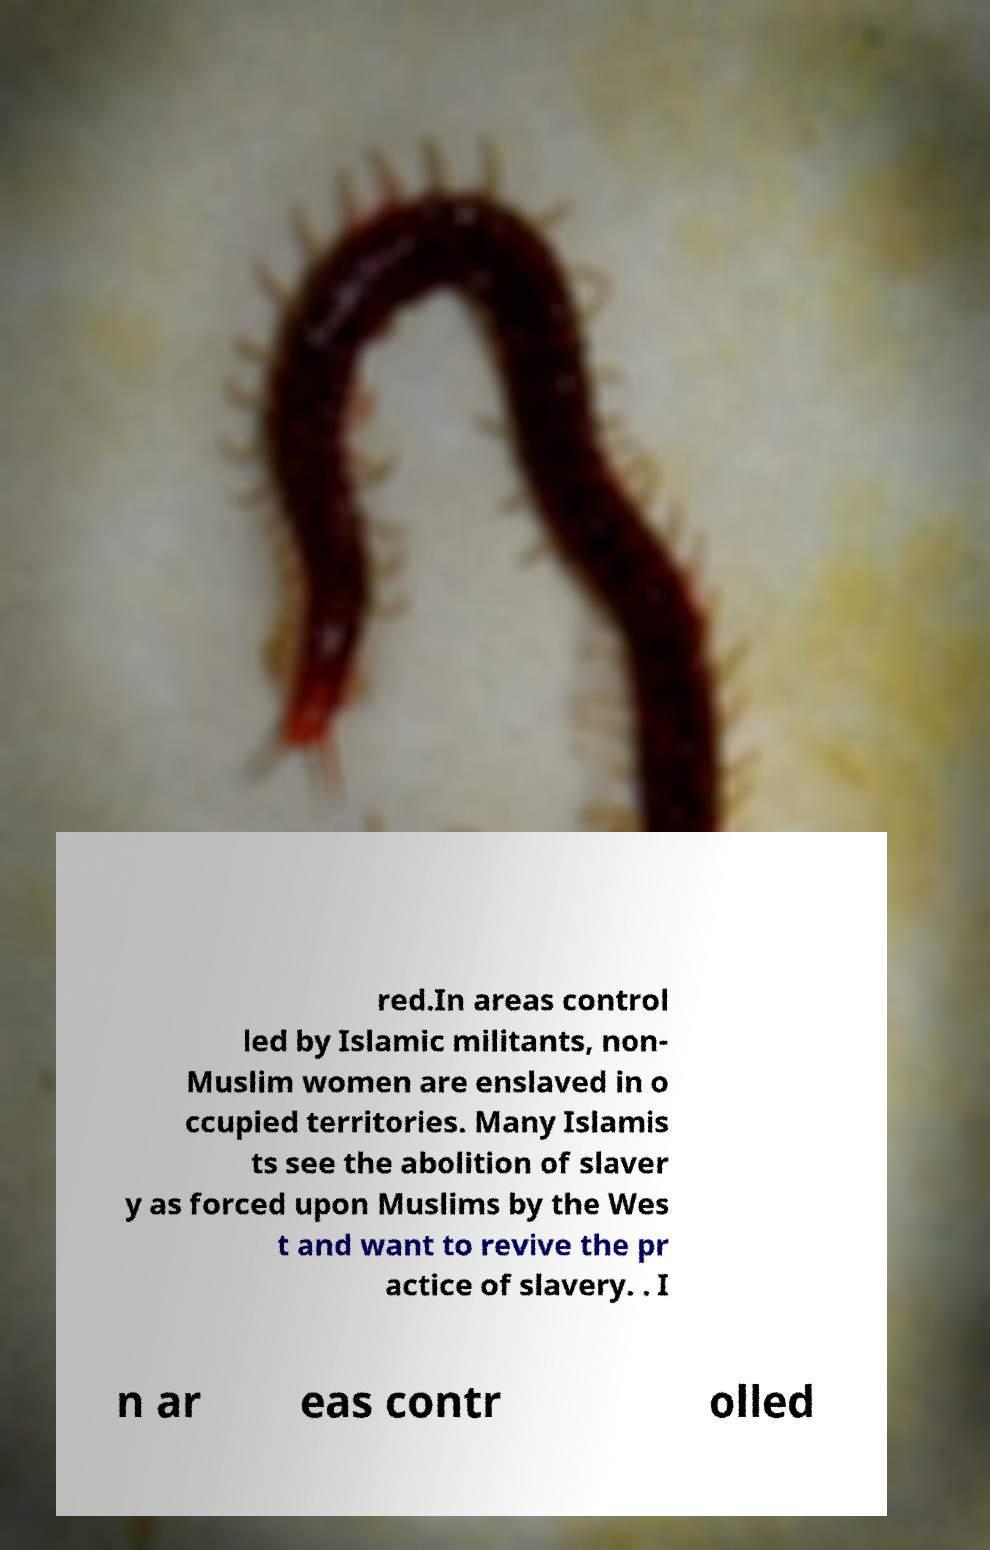I need the written content from this picture converted into text. Can you do that? red.In areas control led by Islamic militants, non- Muslim women are enslaved in o ccupied territories. Many Islamis ts see the abolition of slaver y as forced upon Muslims by the Wes t and want to revive the pr actice of slavery. . I n ar eas contr olled 